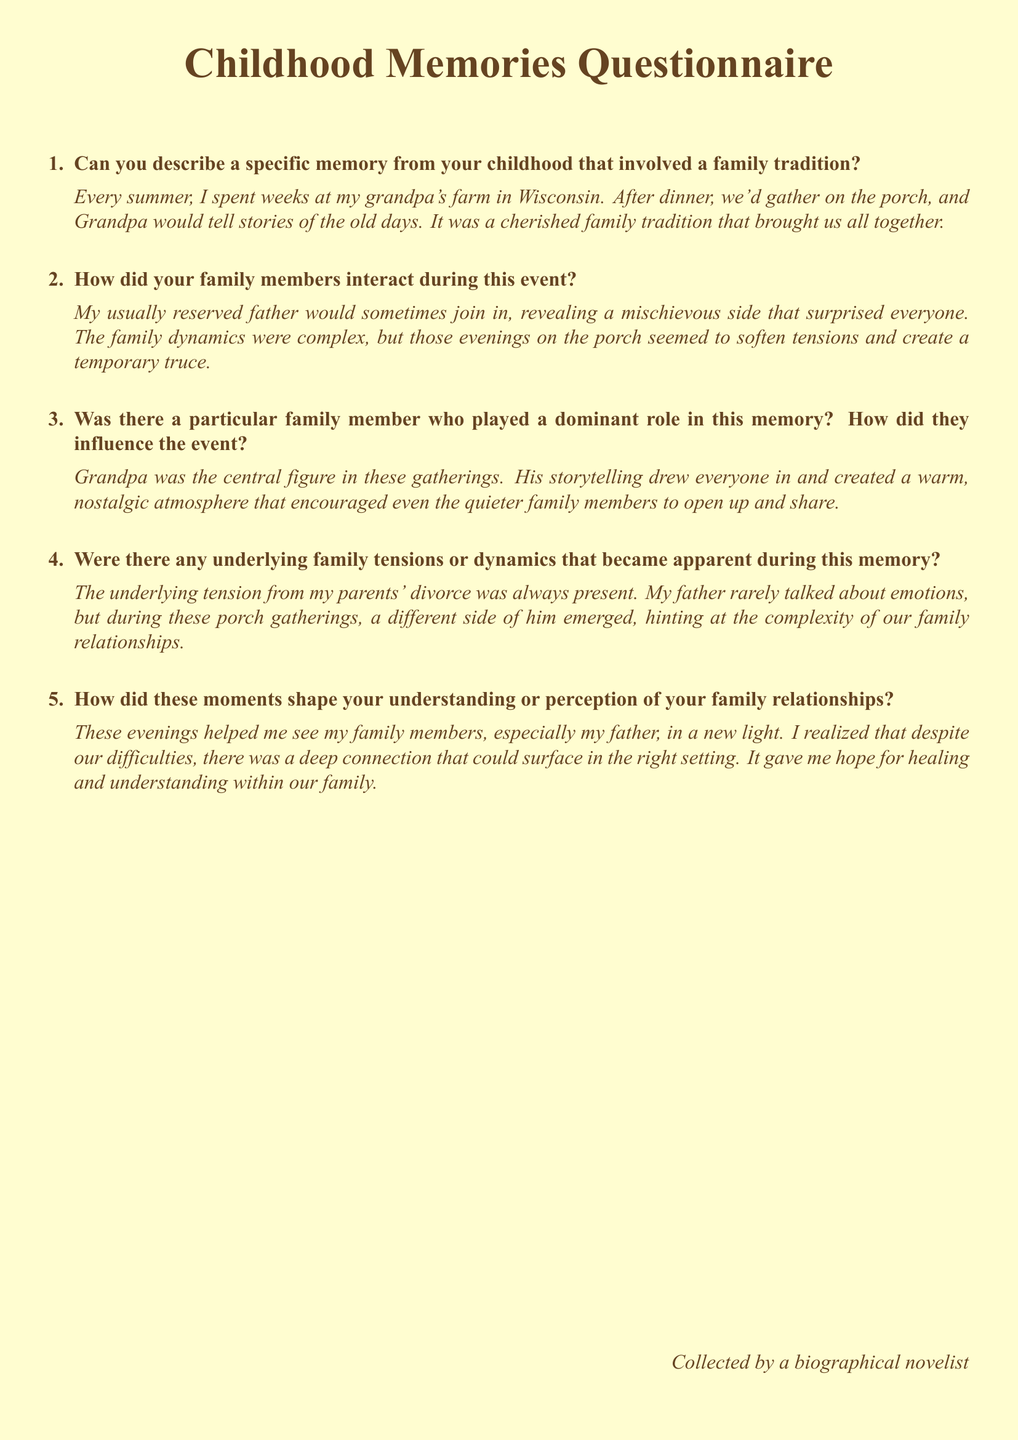What is the title of the document? The title is clearly stated at the top of the document as the section heading.
Answer: Childhood Memories Questionnaire What location is mentioned in the memories? The document references a specific location where family traditions took place, which is part of a memory recollection.
Answer: Wisconsin Who is the central figure in the tradition described? The document identifies a key family member who played a significant role in the narrative of the childhood memory.
Answer: Grandpa What emotion was usually exhibited by the father? The document indicates a characteristic behavior or emotion of the father during family gatherings.
Answer: Reserved What was the family event being discussed? The essence of the memory revolves around a specific event that took place during childhood, mentioned in the first question.
Answer: Gathering on the porch How did the gatherings affect the family dynamics? The document discusses the impact of these gatherings on the family relationships and the atmosphere they created.
Answer: Temporary truce 